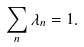Convert formula to latex. <formula><loc_0><loc_0><loc_500><loc_500>\sum _ { n } \lambda _ { n } = 1 .</formula> 